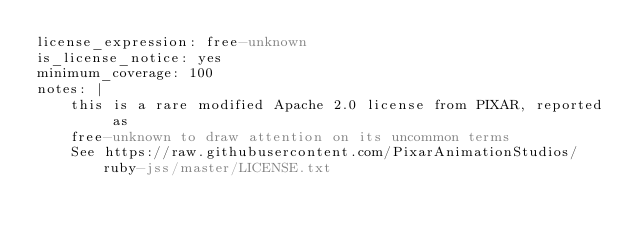Convert code to text. <code><loc_0><loc_0><loc_500><loc_500><_YAML_>license_expression: free-unknown
is_license_notice: yes
minimum_coverage: 100
notes: |
    this is a rare modified Apache 2.0 license from PIXAR, reported as
    free-unknown to draw attention on its uncommon terms
    See https://raw.githubusercontent.com/PixarAnimationStudios/ruby-jss/master/LICENSE.txt
</code> 